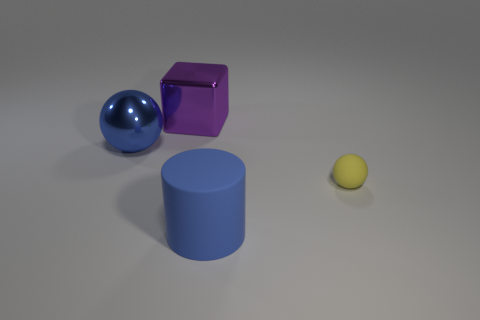Is the size of the ball on the right side of the blue matte object the same as the big purple metallic block?
Provide a succinct answer. No. How many rubber objects are either cylinders or big red balls?
Your response must be concise. 1. How big is the rubber object that is in front of the tiny sphere?
Ensure brevity in your answer.  Large. Does the blue metal thing have the same shape as the tiny yellow rubber thing?
Keep it short and to the point. Yes. What number of small objects are blue spheres or brown things?
Offer a very short reply. 0. Are there any small spheres on the left side of the big blue metal object?
Ensure brevity in your answer.  No. Are there an equal number of blue cylinders behind the big cylinder and large spheres?
Give a very brief answer. No. There is another thing that is the same shape as the yellow matte thing; what size is it?
Your answer should be compact. Large. There is a blue rubber object; does it have the same shape as the large shiny object that is to the right of the shiny ball?
Offer a terse response. No. How big is the blue object that is in front of the blue object behind the big rubber cylinder?
Give a very brief answer. Large. 